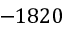<formula> <loc_0><loc_0><loc_500><loc_500>- 1 8 2 0</formula> 